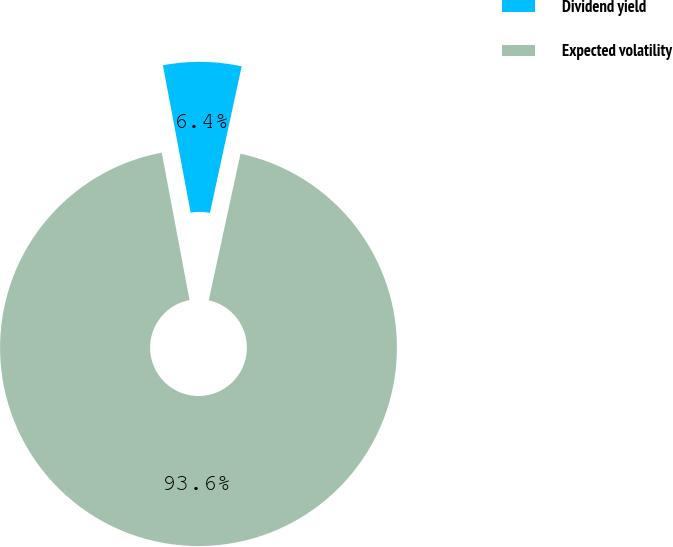Convert chart to OTSL. <chart><loc_0><loc_0><loc_500><loc_500><pie_chart><fcel>Dividend yield<fcel>Expected volatility<nl><fcel>6.36%<fcel>93.64%<nl></chart> 